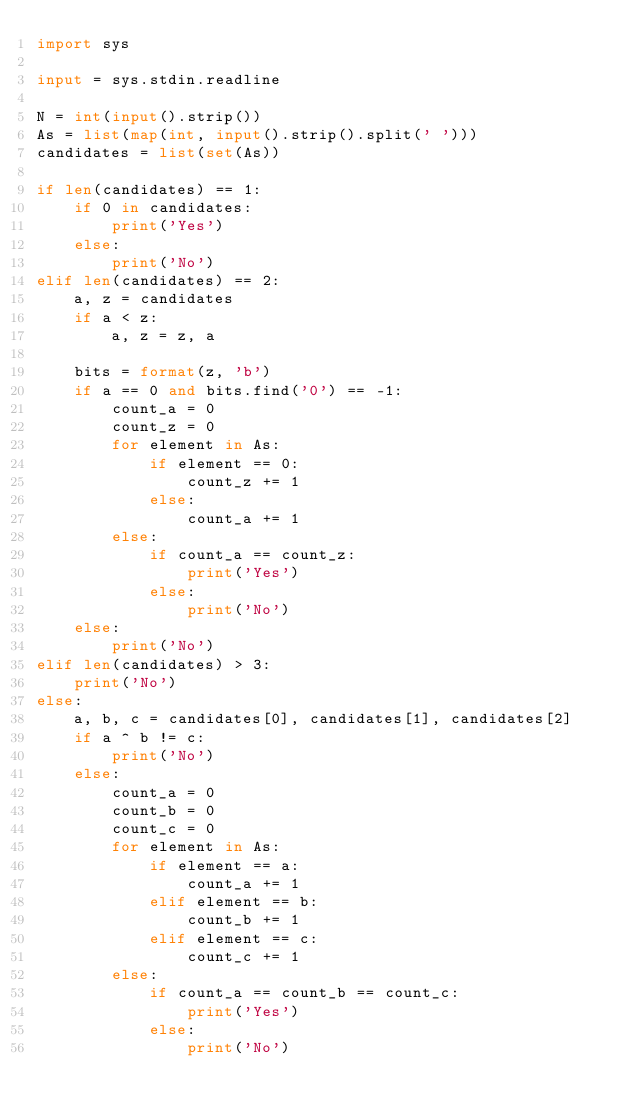<code> <loc_0><loc_0><loc_500><loc_500><_Python_>import sys

input = sys.stdin.readline

N = int(input().strip())
As = list(map(int, input().strip().split(' ')))
candidates = list(set(As))

if len(candidates) == 1:
    if 0 in candidates:
        print('Yes')
    else:
        print('No')
elif len(candidates) == 2:
    a, z = candidates
    if a < z:
        a, z = z, a

    bits = format(z, 'b')
    if a == 0 and bits.find('0') == -1:
        count_a = 0
        count_z = 0
        for element in As:
            if element == 0:
                count_z += 1
            else:
                count_a += 1
        else:
            if count_a == count_z:
                print('Yes')
            else:
                print('No')
    else:
        print('No')
elif len(candidates) > 3:
    print('No')
else:
    a, b, c = candidates[0], candidates[1], candidates[2]
    if a ^ b != c:
        print('No')
    else:
        count_a = 0
        count_b = 0
        count_c = 0
        for element in As:
            if element == a:
                count_a += 1
            elif element == b:
                count_b += 1
            elif element == c:
                count_c += 1
        else:
            if count_a == count_b == count_c:
                print('Yes')
            else:
                print('No')

</code> 